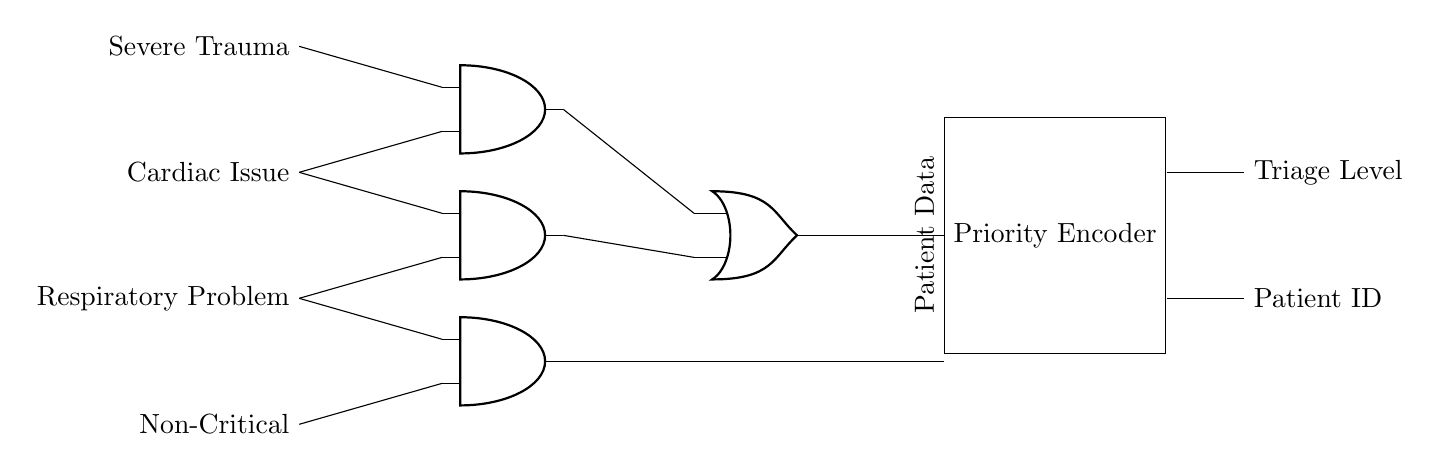What components are present in the circuit diagram? The circuit contains AND gates, an OR gate, and a priority encoder. Each component plays a role in determining patient triage levels based on the severity of their conditions.
Answer: AND gates, OR gate, priority encoder How many AND gates are used in this circuit diagram? There are three AND gates in the circuit diagram. Each AND gate processes different combinations of input signals related to patient conditions.
Answer: Three What function does the OR gate serve in this circuit? The OR gate consolidates the outputs from the AND gates, allowing it to send a single signal indicating that at least one high-priority condition exists, which is crucial for triage decisions.
Answer: Consolidates outputs What is the purpose of the priority encoder in this circuit? The priority encoder's role is to assign a specific triage level and patient ID based on the input signals it receives, which helps in efficiently managing the emergency room patient flow.
Answer: Assigns triage level If a patient has a severe trauma and a cardiac issue, what triage level would be assigned? The presence of both severe trauma and a cardiac issue indicates a higher priority signal would be processed from the AND gates, leading to a determination of the most critical triage level according to the circuit logic.
Answer: Highest triage level Which input signal indicates the least critical condition? The input signal labeled as "Non-Critical" indicates the least critical condition among the input signals represented in the circuit.
Answer: Non-Critical 